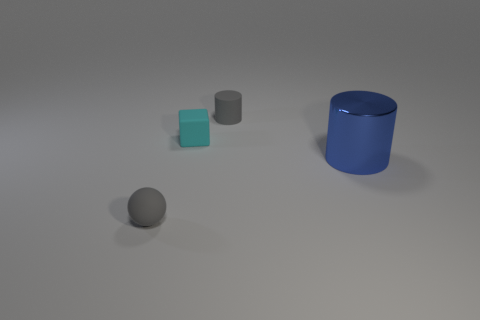Is there anything else that is made of the same material as the blue cylinder?
Your response must be concise. No. Does the ball have the same color as the rubber cylinder?
Your response must be concise. Yes. Are there any small rubber objects that have the same color as the sphere?
Your answer should be very brief. Yes. What number of metal objects are either cyan objects or big objects?
Offer a very short reply. 1. What number of small gray matte balls are behind the small gray matte object on the right side of the rubber ball?
Provide a succinct answer. 0. How many big blue things have the same material as the tiny gray ball?
Ensure brevity in your answer.  0. What number of tiny objects are either gray things or blue metallic cylinders?
Give a very brief answer. 2. There is a small matte object that is both on the right side of the tiny gray rubber ball and in front of the gray rubber cylinder; what shape is it?
Give a very brief answer. Cube. Is the big blue thing made of the same material as the gray cylinder?
Offer a very short reply. No. What color is the matte sphere that is the same size as the gray cylinder?
Give a very brief answer. Gray. 